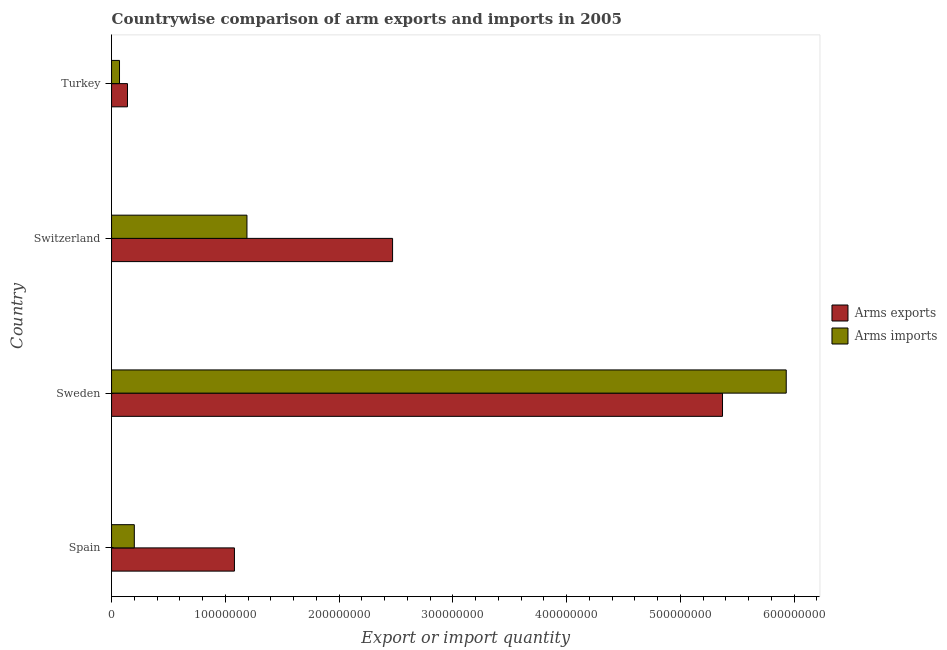How many groups of bars are there?
Your response must be concise. 4. How many bars are there on the 1st tick from the bottom?
Ensure brevity in your answer.  2. What is the label of the 3rd group of bars from the top?
Your answer should be very brief. Sweden. What is the arms imports in Switzerland?
Offer a very short reply. 1.19e+08. Across all countries, what is the maximum arms imports?
Give a very brief answer. 5.93e+08. Across all countries, what is the minimum arms imports?
Provide a succinct answer. 7.00e+06. In which country was the arms exports minimum?
Make the answer very short. Turkey. What is the total arms exports in the graph?
Offer a terse response. 9.06e+08. What is the difference between the arms imports in Switzerland and that in Turkey?
Provide a short and direct response. 1.12e+08. What is the difference between the arms imports in Spain and the arms exports in Switzerland?
Keep it short and to the point. -2.27e+08. What is the average arms imports per country?
Keep it short and to the point. 1.85e+08. What is the difference between the arms imports and arms exports in Turkey?
Your answer should be very brief. -7.00e+06. What is the ratio of the arms exports in Spain to that in Sweden?
Give a very brief answer. 0.2. What is the difference between the highest and the second highest arms imports?
Give a very brief answer. 4.74e+08. What is the difference between the highest and the lowest arms imports?
Offer a terse response. 5.86e+08. What does the 2nd bar from the top in Spain represents?
Give a very brief answer. Arms exports. What does the 2nd bar from the bottom in Switzerland represents?
Offer a very short reply. Arms imports. How many bars are there?
Make the answer very short. 8. What is the difference between two consecutive major ticks on the X-axis?
Offer a very short reply. 1.00e+08. Are the values on the major ticks of X-axis written in scientific E-notation?
Make the answer very short. No. How many legend labels are there?
Give a very brief answer. 2. How are the legend labels stacked?
Offer a terse response. Vertical. What is the title of the graph?
Your answer should be very brief. Countrywise comparison of arm exports and imports in 2005. What is the label or title of the X-axis?
Give a very brief answer. Export or import quantity. What is the label or title of the Y-axis?
Give a very brief answer. Country. What is the Export or import quantity in Arms exports in Spain?
Offer a terse response. 1.08e+08. What is the Export or import quantity in Arms exports in Sweden?
Provide a short and direct response. 5.37e+08. What is the Export or import quantity in Arms imports in Sweden?
Provide a succinct answer. 5.93e+08. What is the Export or import quantity in Arms exports in Switzerland?
Make the answer very short. 2.47e+08. What is the Export or import quantity in Arms imports in Switzerland?
Provide a succinct answer. 1.19e+08. What is the Export or import quantity of Arms exports in Turkey?
Your answer should be compact. 1.40e+07. Across all countries, what is the maximum Export or import quantity in Arms exports?
Your answer should be compact. 5.37e+08. Across all countries, what is the maximum Export or import quantity of Arms imports?
Ensure brevity in your answer.  5.93e+08. Across all countries, what is the minimum Export or import quantity in Arms exports?
Provide a succinct answer. 1.40e+07. Across all countries, what is the minimum Export or import quantity in Arms imports?
Provide a short and direct response. 7.00e+06. What is the total Export or import quantity of Arms exports in the graph?
Ensure brevity in your answer.  9.06e+08. What is the total Export or import quantity of Arms imports in the graph?
Keep it short and to the point. 7.39e+08. What is the difference between the Export or import quantity in Arms exports in Spain and that in Sweden?
Keep it short and to the point. -4.29e+08. What is the difference between the Export or import quantity in Arms imports in Spain and that in Sweden?
Keep it short and to the point. -5.73e+08. What is the difference between the Export or import quantity in Arms exports in Spain and that in Switzerland?
Ensure brevity in your answer.  -1.39e+08. What is the difference between the Export or import quantity in Arms imports in Spain and that in Switzerland?
Keep it short and to the point. -9.90e+07. What is the difference between the Export or import quantity in Arms exports in Spain and that in Turkey?
Your answer should be very brief. 9.40e+07. What is the difference between the Export or import quantity of Arms imports in Spain and that in Turkey?
Ensure brevity in your answer.  1.30e+07. What is the difference between the Export or import quantity of Arms exports in Sweden and that in Switzerland?
Provide a short and direct response. 2.90e+08. What is the difference between the Export or import quantity of Arms imports in Sweden and that in Switzerland?
Provide a short and direct response. 4.74e+08. What is the difference between the Export or import quantity of Arms exports in Sweden and that in Turkey?
Offer a terse response. 5.23e+08. What is the difference between the Export or import quantity of Arms imports in Sweden and that in Turkey?
Provide a succinct answer. 5.86e+08. What is the difference between the Export or import quantity of Arms exports in Switzerland and that in Turkey?
Make the answer very short. 2.33e+08. What is the difference between the Export or import quantity of Arms imports in Switzerland and that in Turkey?
Your response must be concise. 1.12e+08. What is the difference between the Export or import quantity in Arms exports in Spain and the Export or import quantity in Arms imports in Sweden?
Offer a terse response. -4.85e+08. What is the difference between the Export or import quantity in Arms exports in Spain and the Export or import quantity in Arms imports in Switzerland?
Keep it short and to the point. -1.10e+07. What is the difference between the Export or import quantity of Arms exports in Spain and the Export or import quantity of Arms imports in Turkey?
Your answer should be very brief. 1.01e+08. What is the difference between the Export or import quantity in Arms exports in Sweden and the Export or import quantity in Arms imports in Switzerland?
Offer a very short reply. 4.18e+08. What is the difference between the Export or import quantity in Arms exports in Sweden and the Export or import quantity in Arms imports in Turkey?
Your answer should be very brief. 5.30e+08. What is the difference between the Export or import quantity of Arms exports in Switzerland and the Export or import quantity of Arms imports in Turkey?
Keep it short and to the point. 2.40e+08. What is the average Export or import quantity of Arms exports per country?
Your answer should be very brief. 2.26e+08. What is the average Export or import quantity of Arms imports per country?
Keep it short and to the point. 1.85e+08. What is the difference between the Export or import quantity in Arms exports and Export or import quantity in Arms imports in Spain?
Your response must be concise. 8.80e+07. What is the difference between the Export or import quantity of Arms exports and Export or import quantity of Arms imports in Sweden?
Make the answer very short. -5.60e+07. What is the difference between the Export or import quantity of Arms exports and Export or import quantity of Arms imports in Switzerland?
Your response must be concise. 1.28e+08. What is the ratio of the Export or import quantity of Arms exports in Spain to that in Sweden?
Offer a very short reply. 0.2. What is the ratio of the Export or import quantity of Arms imports in Spain to that in Sweden?
Give a very brief answer. 0.03. What is the ratio of the Export or import quantity of Arms exports in Spain to that in Switzerland?
Make the answer very short. 0.44. What is the ratio of the Export or import quantity in Arms imports in Spain to that in Switzerland?
Make the answer very short. 0.17. What is the ratio of the Export or import quantity in Arms exports in Spain to that in Turkey?
Offer a terse response. 7.71. What is the ratio of the Export or import quantity in Arms imports in Spain to that in Turkey?
Give a very brief answer. 2.86. What is the ratio of the Export or import quantity in Arms exports in Sweden to that in Switzerland?
Keep it short and to the point. 2.17. What is the ratio of the Export or import quantity in Arms imports in Sweden to that in Switzerland?
Your answer should be very brief. 4.98. What is the ratio of the Export or import quantity of Arms exports in Sweden to that in Turkey?
Provide a short and direct response. 38.36. What is the ratio of the Export or import quantity of Arms imports in Sweden to that in Turkey?
Provide a succinct answer. 84.71. What is the ratio of the Export or import quantity of Arms exports in Switzerland to that in Turkey?
Make the answer very short. 17.64. What is the ratio of the Export or import quantity of Arms imports in Switzerland to that in Turkey?
Your answer should be very brief. 17. What is the difference between the highest and the second highest Export or import quantity in Arms exports?
Provide a succinct answer. 2.90e+08. What is the difference between the highest and the second highest Export or import quantity of Arms imports?
Offer a terse response. 4.74e+08. What is the difference between the highest and the lowest Export or import quantity in Arms exports?
Keep it short and to the point. 5.23e+08. What is the difference between the highest and the lowest Export or import quantity of Arms imports?
Offer a terse response. 5.86e+08. 